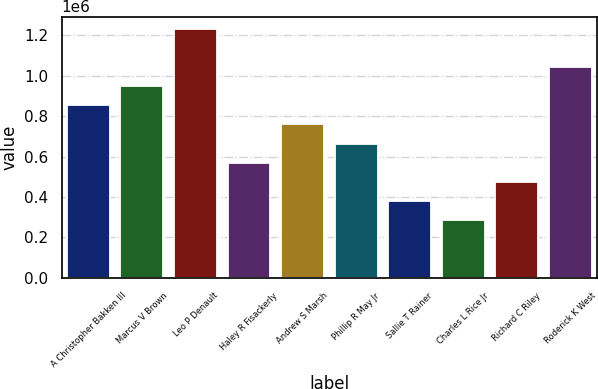Convert chart to OTSL. <chart><loc_0><loc_0><loc_500><loc_500><bar_chart><fcel>A Christopher Bakken III<fcel>Marcus V Brown<fcel>Leo P Denault<fcel>Haley R Fisackerly<fcel>Andrew S Marsh<fcel>Phillip R May Jr<fcel>Sallie T Rainer<fcel>Charles L Rice Jr<fcel>Richard C Riley<fcel>Roderick K West<nl><fcel>852570<fcel>946927<fcel>1.23e+06<fcel>569497<fcel>758212<fcel>663854<fcel>380782<fcel>286424<fcel>475139<fcel>1.04128e+06<nl></chart> 